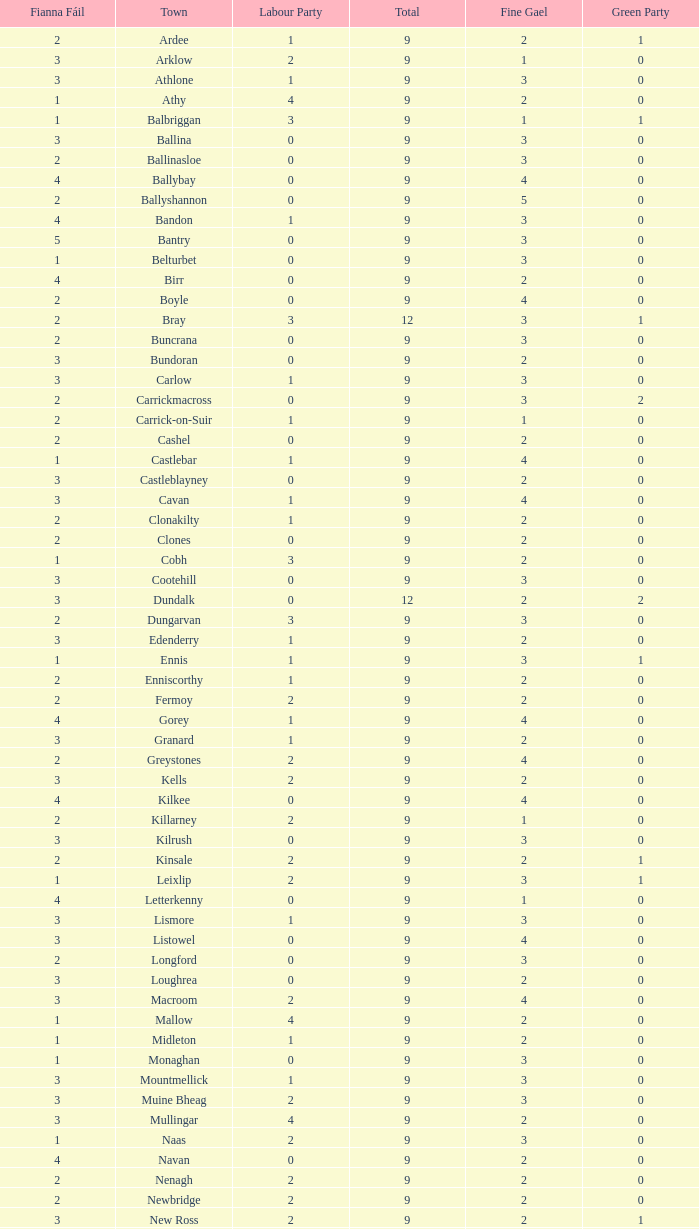Could you help me parse every detail presented in this table? {'header': ['Fianna Fáil', 'Town', 'Labour Party', 'Total', 'Fine Gael', 'Green Party'], 'rows': [['2', 'Ardee', '1', '9', '2', '1'], ['3', 'Arklow', '2', '9', '1', '0'], ['3', 'Athlone', '1', '9', '3', '0'], ['1', 'Athy', '4', '9', '2', '0'], ['1', 'Balbriggan', '3', '9', '1', '1'], ['3', 'Ballina', '0', '9', '3', '0'], ['2', 'Ballinasloe', '0', '9', '3', '0'], ['4', 'Ballybay', '0', '9', '4', '0'], ['2', 'Ballyshannon', '0', '9', '5', '0'], ['4', 'Bandon', '1', '9', '3', '0'], ['5', 'Bantry', '0', '9', '3', '0'], ['1', 'Belturbet', '0', '9', '3', '0'], ['4', 'Birr', '0', '9', '2', '0'], ['2', 'Boyle', '0', '9', '4', '0'], ['2', 'Bray', '3', '12', '3', '1'], ['2', 'Buncrana', '0', '9', '3', '0'], ['3', 'Bundoran', '0', '9', '2', '0'], ['3', 'Carlow', '1', '9', '3', '0'], ['2', 'Carrickmacross', '0', '9', '3', '2'], ['2', 'Carrick-on-Suir', '1', '9', '1', '0'], ['2', 'Cashel', '0', '9', '2', '0'], ['1', 'Castlebar', '1', '9', '4', '0'], ['3', 'Castleblayney', '0', '9', '2', '0'], ['3', 'Cavan', '1', '9', '4', '0'], ['2', 'Clonakilty', '1', '9', '2', '0'], ['2', 'Clones', '0', '9', '2', '0'], ['1', 'Cobh', '3', '9', '2', '0'], ['3', 'Cootehill', '0', '9', '3', '0'], ['3', 'Dundalk', '0', '12', '2', '2'], ['2', 'Dungarvan', '3', '9', '3', '0'], ['3', 'Edenderry', '1', '9', '2', '0'], ['1', 'Ennis', '1', '9', '3', '1'], ['2', 'Enniscorthy', '1', '9', '2', '0'], ['2', 'Fermoy', '2', '9', '2', '0'], ['4', 'Gorey', '1', '9', '4', '0'], ['3', 'Granard', '1', '9', '2', '0'], ['2', 'Greystones', '2', '9', '4', '0'], ['3', 'Kells', '2', '9', '2', '0'], ['4', 'Kilkee', '0', '9', '4', '0'], ['2', 'Killarney', '2', '9', '1', '0'], ['3', 'Kilrush', '0', '9', '3', '0'], ['2', 'Kinsale', '2', '9', '2', '1'], ['1', 'Leixlip', '2', '9', '3', '1'], ['4', 'Letterkenny', '0', '9', '1', '0'], ['3', 'Lismore', '1', '9', '3', '0'], ['3', 'Listowel', '0', '9', '4', '0'], ['2', 'Longford', '0', '9', '3', '0'], ['3', 'Loughrea', '0', '9', '2', '0'], ['3', 'Macroom', '2', '9', '4', '0'], ['1', 'Mallow', '4', '9', '2', '0'], ['1', 'Midleton', '1', '9', '2', '0'], ['1', 'Monaghan', '0', '9', '3', '0'], ['3', 'Mountmellick', '1', '9', '3', '0'], ['3', 'Muine Bheag', '2', '9', '3', '0'], ['3', 'Mullingar', '4', '9', '2', '0'], ['1', 'Naas', '2', '9', '3', '0'], ['4', 'Navan', '0', '9', '2', '0'], ['2', 'Nenagh', '2', '9', '2', '0'], ['2', 'Newbridge', '2', '9', '2', '0'], ['3', 'New Ross', '2', '9', '2', '1'], ['2', 'Passage West', '0', '9', '3', '0'], ['2', 'Portlaoise', '0', '9', '3', '0'], ['0', 'Shannon', '2', '9', '4', '0'], ['2', 'Skibbereen', '2', '9', '4', '0'], ['3', 'Templemore', '0', '9', '3', '0'], ['1', 'Thurles', '2', '9', '1', '0'], ['3', 'Tipperary', '1', '9', '1', '0'], ['2', 'Tralee', '3', '12', '3', '0'], ['1', 'Tramore', '1', '9', '4', '0'], ['2', 'Trim', '2', '9', '3', '0'], ['3', 'Tuam', '2', '9', '2', '0'], ['4', 'Tullamore', '2', '9', '2', '0'], ['2', 'Westport', '1', '9', '5', '0'], ['1', 'Wicklow', '1', '9', '3', '1'], ['3', 'Youghal', '1', '9', '2', '1']]} How many are in the Labour Party of a Fianna Fail of 3 with a total higher than 9 and more than 2 in the Green Party? None. 